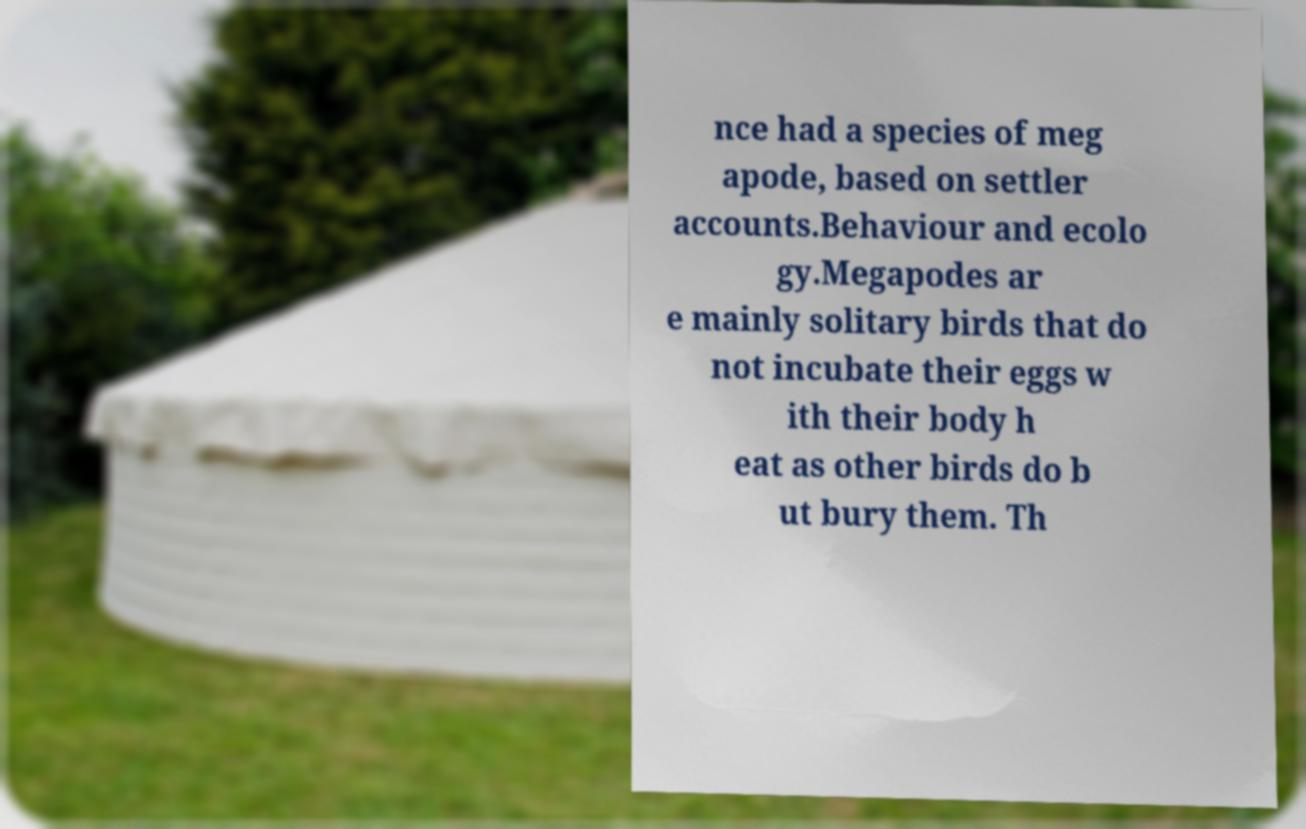What messages or text are displayed in this image? I need them in a readable, typed format. nce had a species of meg apode, based on settler accounts.Behaviour and ecolo gy.Megapodes ar e mainly solitary birds that do not incubate their eggs w ith their body h eat as other birds do b ut bury them. Th 